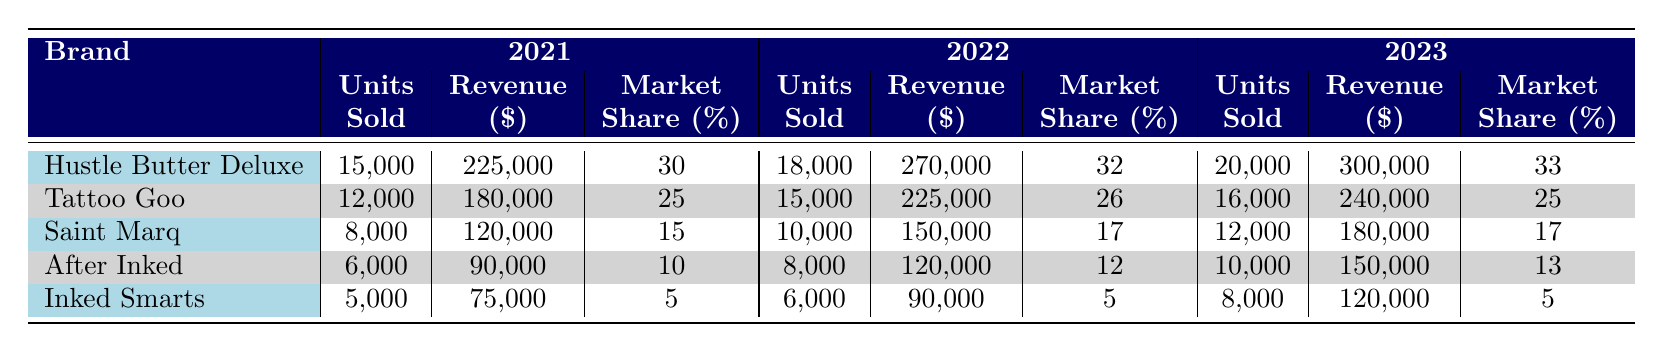What was the revenue from Hustle Butter Deluxe in 2022? The table shows the revenue for Hustle Butter Deluxe under the year 2022, which is $270,000.
Answer: 270000 Which brand had the highest market share in 2023? In 2023, Hustle Butter Deluxe had the highest market share at 33%.
Answer: 33 What is the total units sold by Tattoo Goo from 2021 to 2023? The units sold by Tattoo Goo over the years are: 12,000 in 2021, 15,000 in 2022, and 16,000 in 2023. Adding these gives 12,000 + 15,000 + 16,000 = 43,000.
Answer: 43000 Did After Inked's market share increase from 2021 to 2023? The market share for After Inked was 10% in 2021, 12% in 2022, and 13% in 2023, showing a consistent increase over these years.
Answer: Yes What is the average revenue of all brands in 2023? To find the average revenue, first list the revenues: Hustle Butter Deluxe is 300,000, Tattoo Goo is 240,000, Saint Marq is 180,000, After Inked is 150,000, and Inked Smarts is 120,000. The total revenue is 300,000 + 240,000 + 180,000 + 150,000 + 120,000 = 1,090,000. Since there are 5 brands, the average is 1,090,000 / 5 = 218,000.
Answer: 218000 